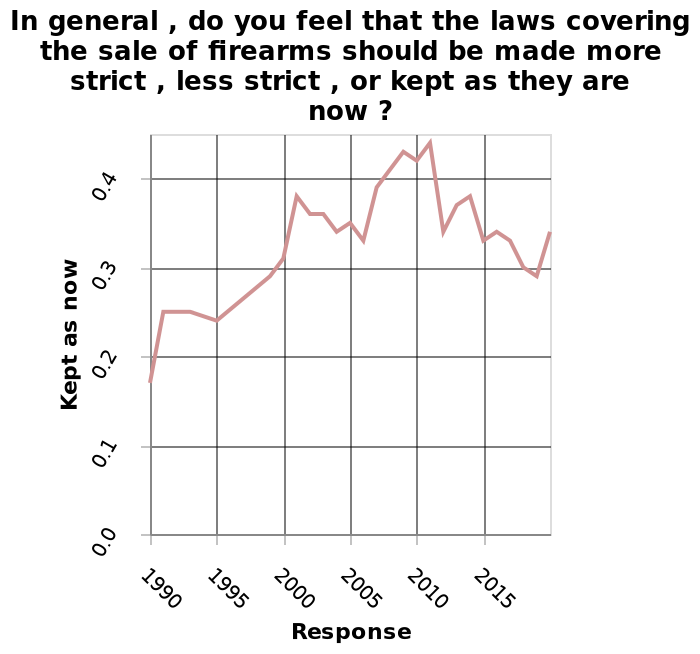<image>
Is the line graph depicting the change in the strictness of laws covering the sale of firearms over time? No, the line graph does not depict the change in the strictness of laws. It only measures the response for keeping the laws as they are now. What was the trend in the number of people who felt gun laws should remain the same between 1990 and 2015?  The number of people who felt gun laws should remain the same increased between 1990 and 2015. 